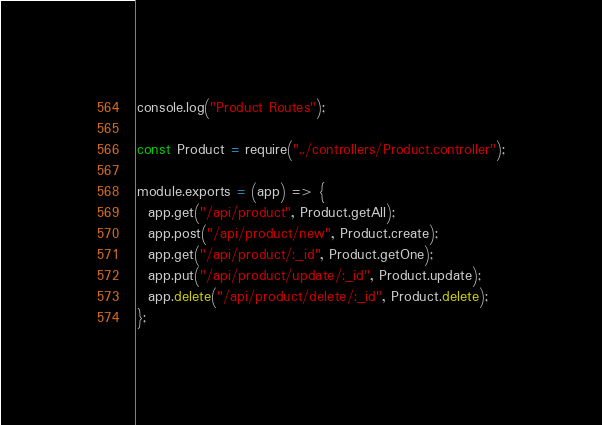<code> <loc_0><loc_0><loc_500><loc_500><_JavaScript_>console.log("Product Routes");

const Product = require("../controllers/Product.controller");

module.exports = (app) => {
  app.get("/api/product", Product.getAll);
  app.post("/api/product/new", Product.create);
  app.get("/api/product/:_id", Product.getOne);
  app.put("/api/product/update/:_id", Product.update);
  app.delete("/api/product/delete/:_id", Product.delete);
};
</code> 